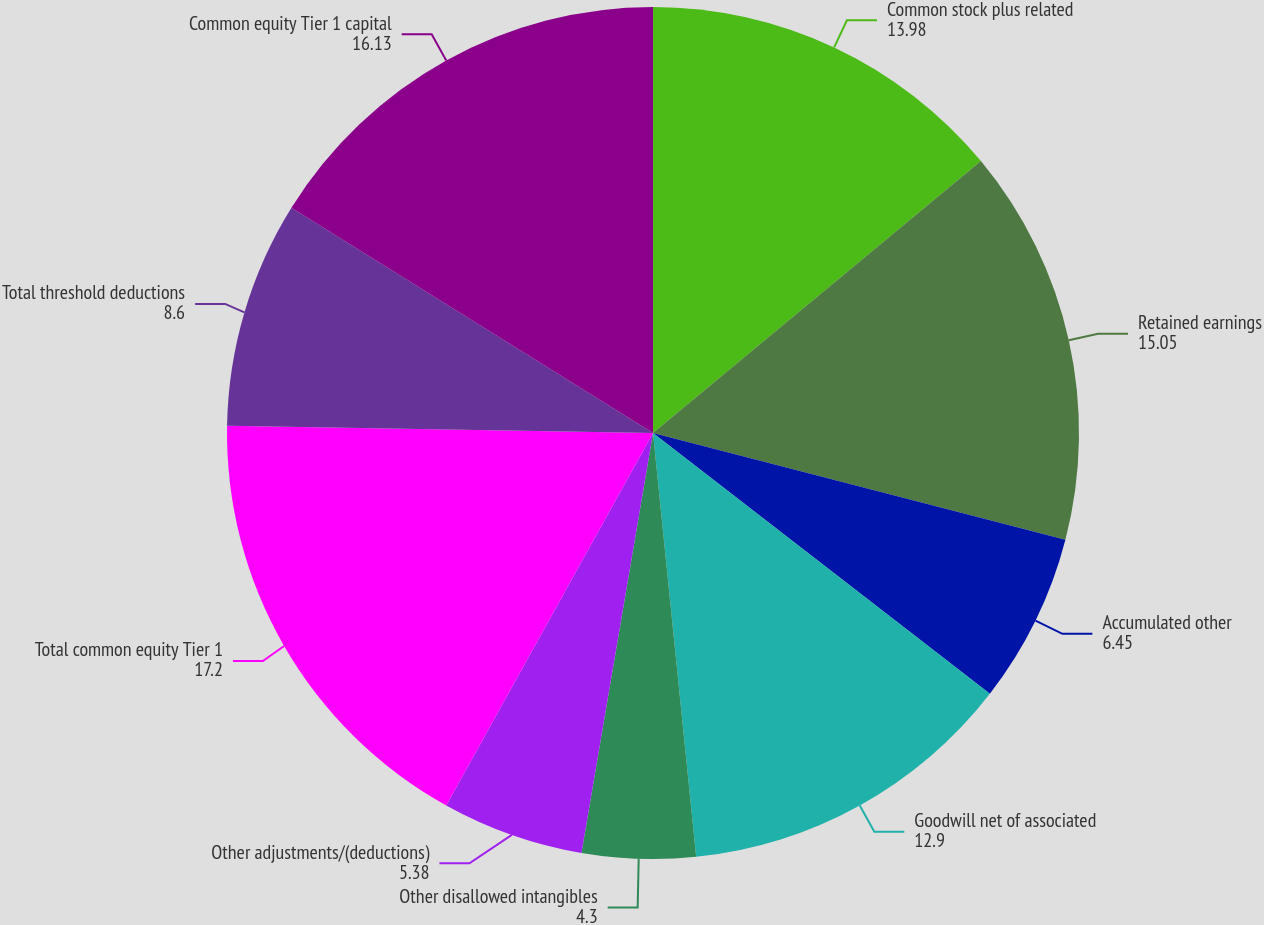<chart> <loc_0><loc_0><loc_500><loc_500><pie_chart><fcel>Common stock plus related<fcel>Retained earnings<fcel>Accumulated other<fcel>Goodwill net of associated<fcel>Other disallowed intangibles<fcel>Other adjustments/(deductions)<fcel>Total common equity Tier 1<fcel>Total threshold deductions<fcel>Common equity Tier 1 capital<nl><fcel>13.98%<fcel>15.05%<fcel>6.45%<fcel>12.9%<fcel>4.3%<fcel>5.38%<fcel>17.2%<fcel>8.6%<fcel>16.13%<nl></chart> 